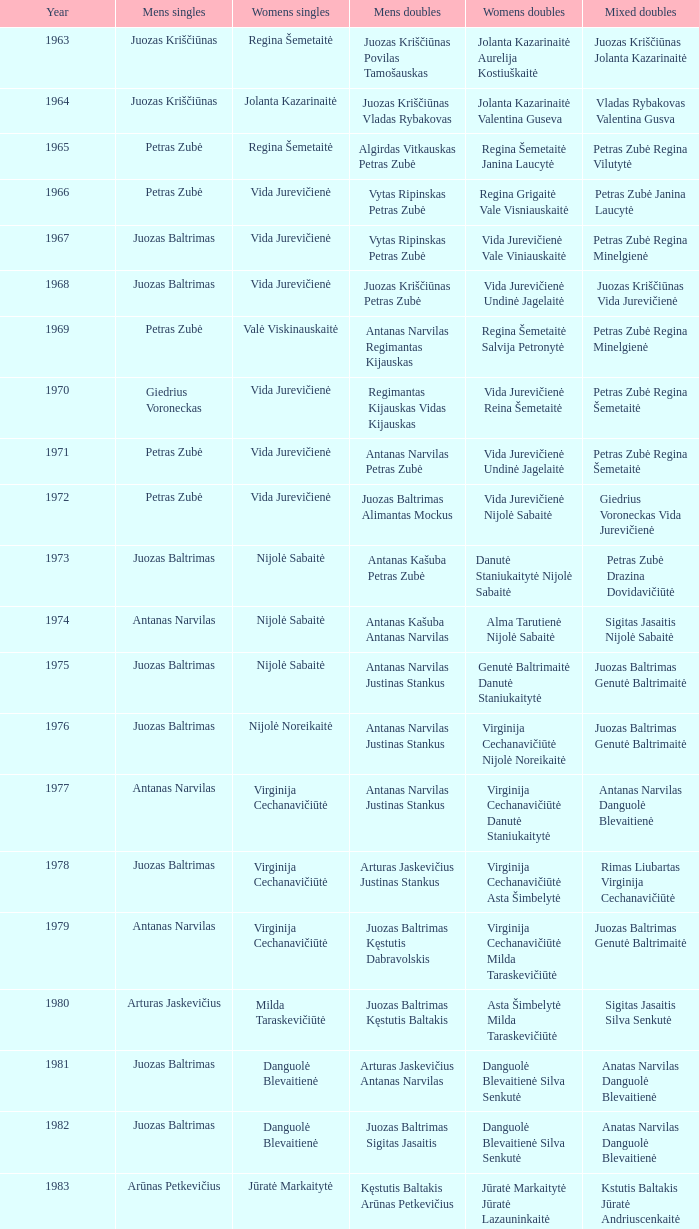How many years did aivaras kvedarauskas juozas spelveris compete in the men's doubles? 1.0. 